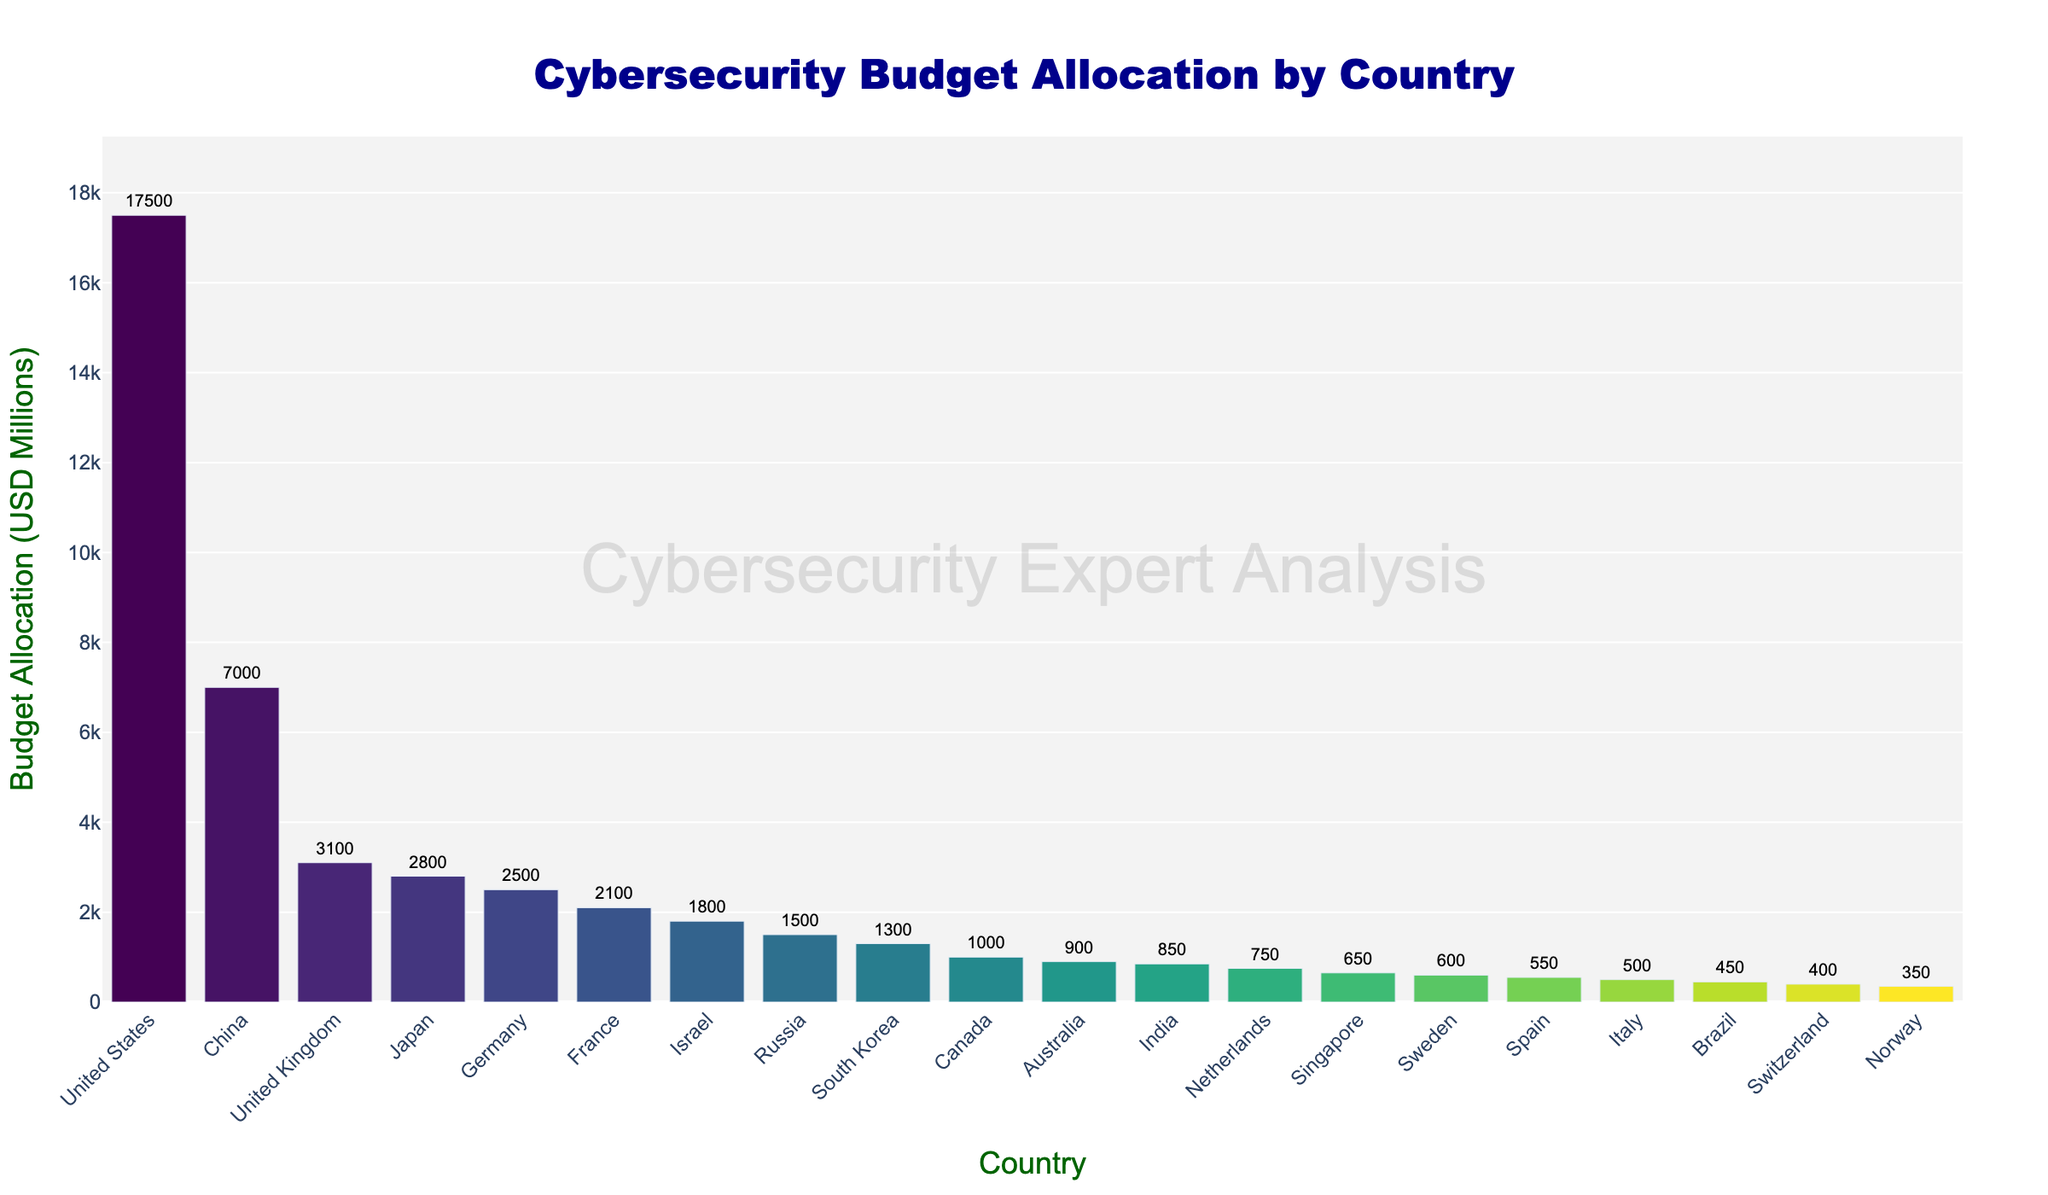Which country has the highest cybersecurity budget allocation? From the bar chart, the United States has the tallest bar indicating the largest budget allocation.
Answer: United States What is the budget allocation for Australia? By looking at the bar corresponding to Australia, the text displays 900 million USD.
Answer: 900 million USD How much more does the United States spend compared to China on cybersecurity? The United States' allocation is 17,500 million USD and China's is 7,000 million USD, so the difference is 17,500 - 7,000 = 10,500 million USD.
Answer: 10,500 million USD Which countries have a budget allocation greater than 2,000 million USD but less than 5,000 million USD? By scanning the chart, the countries with bars between these amounts are the United Kingdom (3,100), Japan (2,800), Germany (2,500), and France (2,100).
Answer: United Kingdom, Japan, Germany, France What is the sum of the budget allocations for Israel, Russia, and South Korea? The budget allocations are Israel 1,800 million USD, Russia 1,500 million USD, and South Korea 1,300 million USD. The sum is 1,800 + 1,500 + 1,300 = 4,600 million USD.
Answer: 4,600 million USD Are there more countries with a budget allocation above or below 1,000 million USD? Count the bars: Above 1,000 million USD are 9 countries, and below 1,000 million USD are 12 countries.
Answer: Below What is the average budget allocation of the top 5 countries? The top 5 countries' allocations are 17,500, 7,000, 3,100, 2,800, and 2,500 million USD. Sum = 32,900 million USD, average = 32,900 / 5 = 6,580 million USD.
Answer: 6,580 million USD Which country has the smallest budget allocation for cybersecurity? The shortest bar corresponds to Norway, with a budget allocation of 350 million USD.
Answer: Norway How much is the combined budget allocation of all the European countries listed? European countries: United Kingdom (3,100), Germany (2,500), France (2,100), Netherlands (750), Sweden (600), Spain (550), Italy (500), Switzerland (400), Norway (350), combined sum = 10,850 million USD.
Answer: 10,850 million USD What percentage of the total budget allocation does India's budget represent? India's budget = 850 million USD; total budget sum (adding each value from the chart) ≈ 45,400 million USD; percentage = (850 / 45,400) * 100 ≈ 1.87%.
Answer: 1.87% 